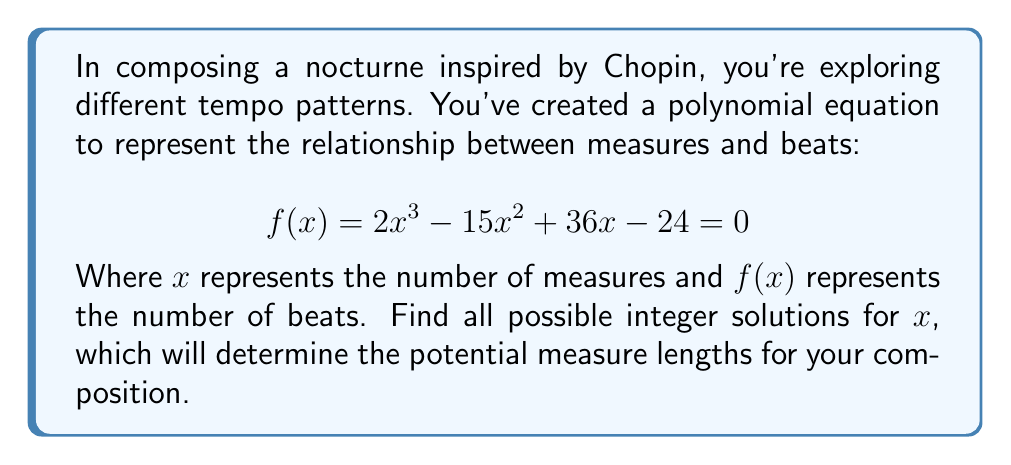Can you answer this question? To solve this polynomial equation, we'll use the rational root theorem and synthetic division:

1) First, let's identify potential rational roots using the factors of the constant term:
   Factors of 24: ±1, ±2, ±3, ±4, ±6, ±8, ±12, ±24

2) Now, let's use synthetic division to test these potential roots:

   Testing x = 1:
   $$
   \begin{array}{r}
   2 \enclose{longdiv}{1 \quad -15 \quad 36 \quad -24} \\
   \underline{2 \quad -13 \quad 23} \\
   1 \quad -13 \quad 23 \quad -1
   \end{array}
   $$
   The remainder is -1, so 1 is not a root.

   Testing x = 2:
   $$
   \begin{array}{r}
   2 \enclose{longdiv}{1 \quad -15 \quad 36 \quad -24} \\
   \underline{2 \quad -26 \quad 22} \\
   1 \quad -13 \quad 10 \quad -2
   \end{array}
   $$
   The remainder is -2, so 2 is not a root.

   Testing x = 3:
   $$
   \begin{array}{r}
   2 \enclose{longdiv}{1 \quad -15 \quad 36 \quad -24} \\
   \underline{3 \quad -36 \quad 0} \\
   1 \quad -12 \quad 0 \quad 0
   \end{array}
   $$
   The remainder is 0, so 3 is a root.

3) Now that we've found one root (x = 3), we can factor out (x - 3):
   $f(x) = (x - 3)(2x^2 - 9x + 8)$

4) We can solve the quadratic equation $2x^2 - 9x + 8 = 0$ using the quadratic formula:
   $$x = \frac{-b \pm \sqrt{b^2 - 4ac}}{2a}$$
   $$x = \frac{9 \pm \sqrt{81 - 64}}{4} = \frac{9 \pm \sqrt{17}}{4}$$

5) The solutions to this quadratic are not integers, so our only integer solution is x = 3.

Therefore, the only integer solution for the equation is x = 3.
Answer: x = 3 